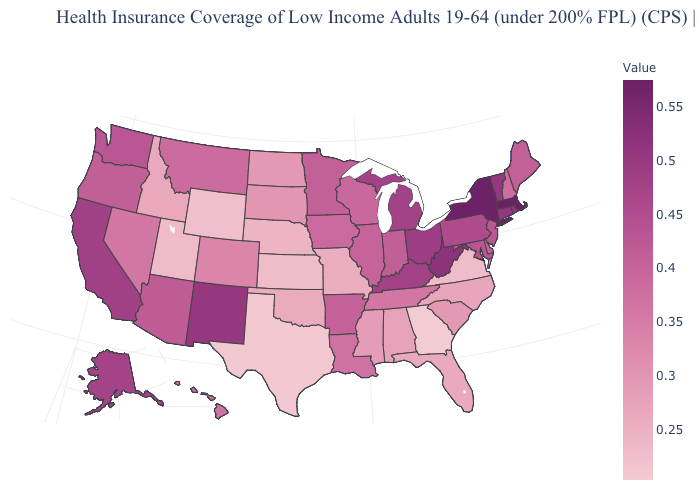Which states hav the highest value in the West?
Give a very brief answer. New Mexico. Which states have the lowest value in the USA?
Short answer required. Georgia. Which states hav the highest value in the Northeast?
Answer briefly. Massachusetts. Which states have the lowest value in the USA?
Answer briefly. Georgia. Does the map have missing data?
Short answer required. No. 